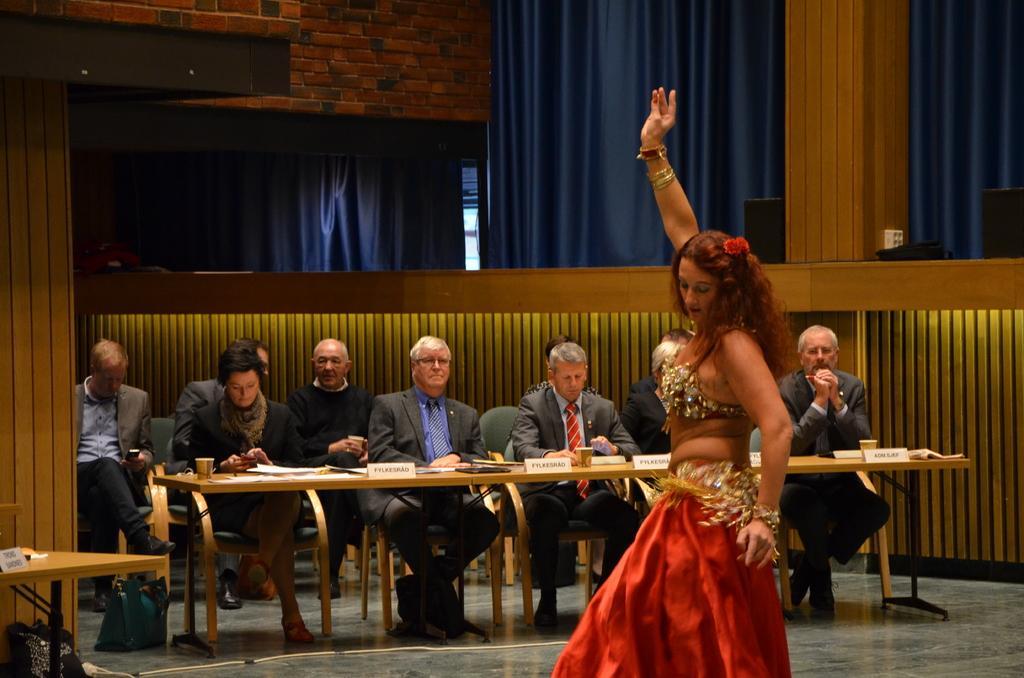Could you give a brief overview of what you see in this image? On the background we can see a wall with bricks and blue colour curtains. Here we can see all the persons sitting on chairs in front of a table and on the table we can see glasses, name boards and mike's. In Front of a picture we can see a girl , wearing a beautiful dress in red colour and dancing. These are bags on the floor. 